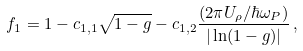<formula> <loc_0><loc_0><loc_500><loc_500>f _ { 1 } = 1 - c _ { 1 , 1 } \sqrt { 1 - g } - c _ { 1 , 2 } \frac { ( 2 \pi U _ { \rho } / \hbar { \omega } _ { P } ) } { | \ln ( 1 - g ) | } \, ,</formula> 